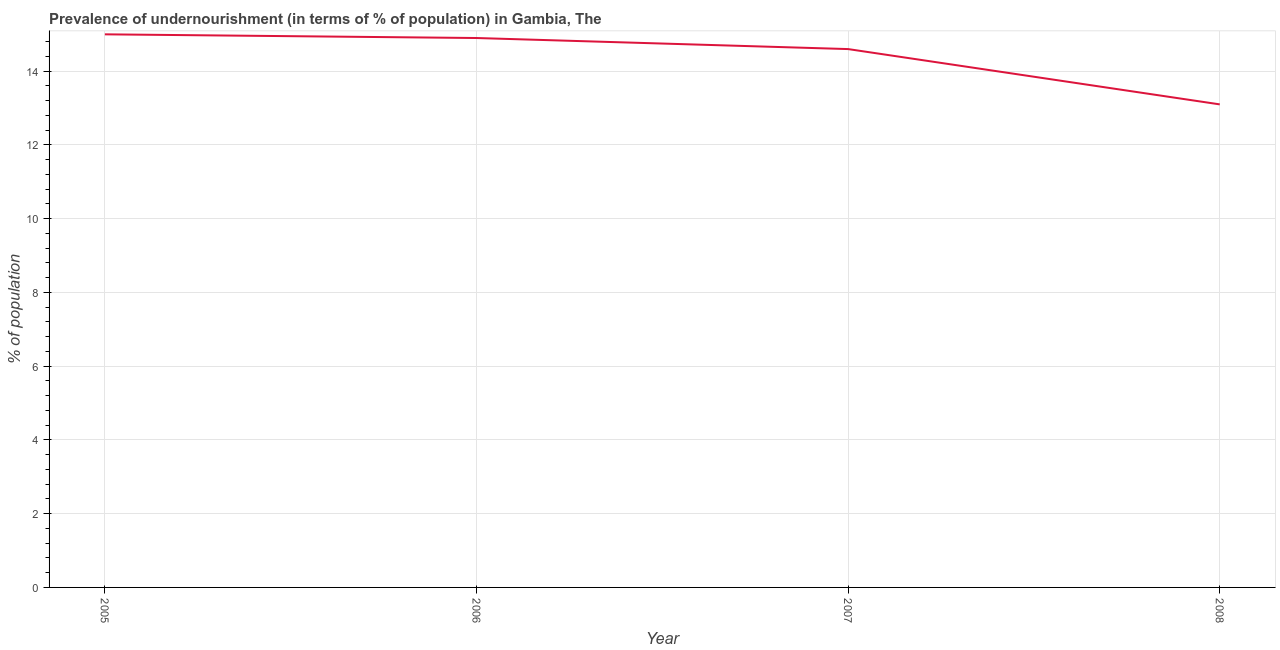Across all years, what is the maximum percentage of undernourished population?
Make the answer very short. 15. What is the sum of the percentage of undernourished population?
Your response must be concise. 57.6. What is the difference between the percentage of undernourished population in 2006 and 2007?
Give a very brief answer. 0.3. What is the average percentage of undernourished population per year?
Your answer should be compact. 14.4. What is the median percentage of undernourished population?
Offer a very short reply. 14.75. In how many years, is the percentage of undernourished population greater than 8.8 %?
Your answer should be very brief. 4. What is the ratio of the percentage of undernourished population in 2007 to that in 2008?
Provide a short and direct response. 1.11. Is the difference between the percentage of undernourished population in 2005 and 2007 greater than the difference between any two years?
Ensure brevity in your answer.  No. What is the difference between the highest and the second highest percentage of undernourished population?
Give a very brief answer. 0.1. Is the sum of the percentage of undernourished population in 2005 and 2006 greater than the maximum percentage of undernourished population across all years?
Your answer should be very brief. Yes. What is the difference between the highest and the lowest percentage of undernourished population?
Provide a short and direct response. 1.9. In how many years, is the percentage of undernourished population greater than the average percentage of undernourished population taken over all years?
Keep it short and to the point. 3. Does the percentage of undernourished population monotonically increase over the years?
Provide a succinct answer. No. How many lines are there?
Give a very brief answer. 1. Does the graph contain grids?
Ensure brevity in your answer.  Yes. What is the title of the graph?
Your answer should be very brief. Prevalence of undernourishment (in terms of % of population) in Gambia, The. What is the label or title of the X-axis?
Offer a very short reply. Year. What is the label or title of the Y-axis?
Your response must be concise. % of population. What is the % of population of 2005?
Provide a succinct answer. 15. What is the % of population of 2006?
Provide a succinct answer. 14.9. What is the % of population in 2007?
Ensure brevity in your answer.  14.6. What is the difference between the % of population in 2005 and 2006?
Provide a short and direct response. 0.1. What is the difference between the % of population in 2006 and 2007?
Your answer should be very brief. 0.3. What is the difference between the % of population in 2006 and 2008?
Make the answer very short. 1.8. What is the ratio of the % of population in 2005 to that in 2006?
Keep it short and to the point. 1.01. What is the ratio of the % of population in 2005 to that in 2008?
Offer a very short reply. 1.15. What is the ratio of the % of population in 2006 to that in 2008?
Ensure brevity in your answer.  1.14. What is the ratio of the % of population in 2007 to that in 2008?
Your answer should be compact. 1.11. 